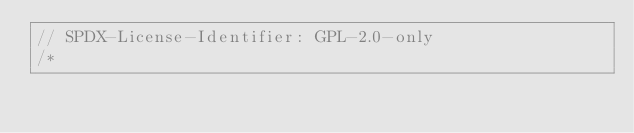Convert code to text. <code><loc_0><loc_0><loc_500><loc_500><_C_>// SPDX-License-Identifier: GPL-2.0-only
/*</code> 